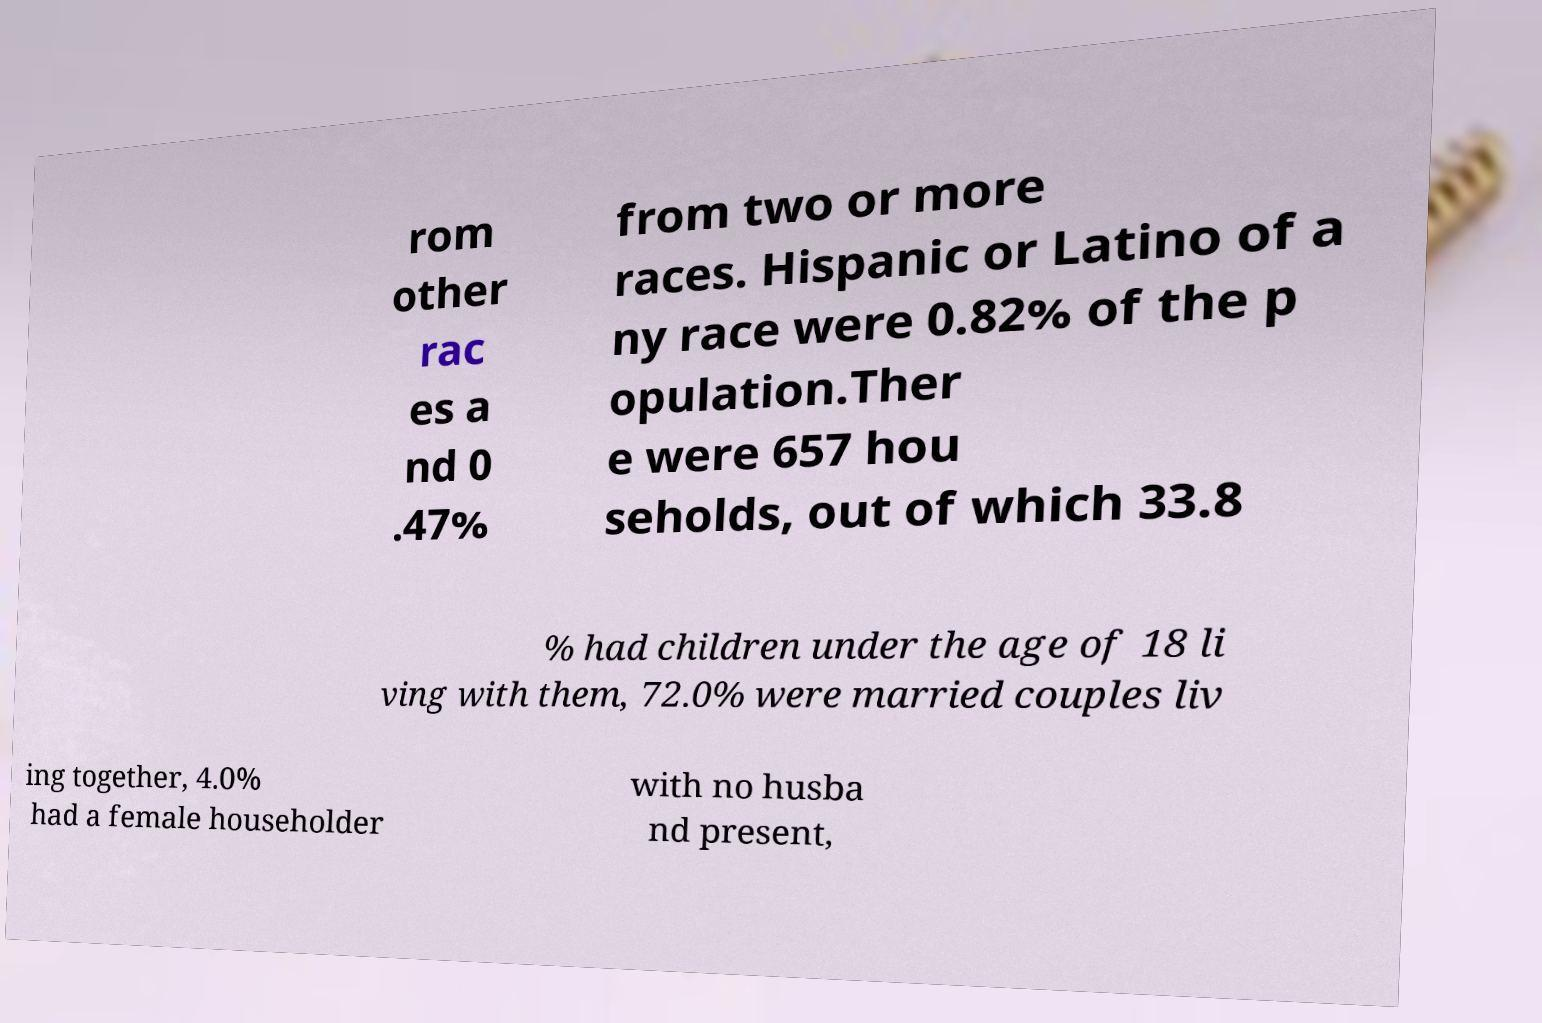Please read and relay the text visible in this image. What does it say? rom other rac es a nd 0 .47% from two or more races. Hispanic or Latino of a ny race were 0.82% of the p opulation.Ther e were 657 hou seholds, out of which 33.8 % had children under the age of 18 li ving with them, 72.0% were married couples liv ing together, 4.0% had a female householder with no husba nd present, 